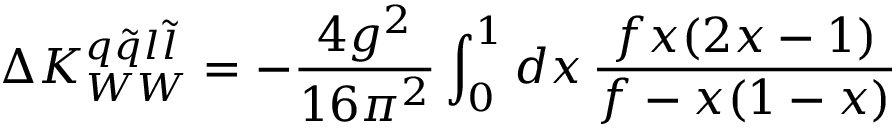Convert formula to latex. <formula><loc_0><loc_0><loc_500><loc_500>\Delta K _ { W W } ^ { q \tilde { q } l \tilde { l } } = - \frac { 4 g ^ { 2 } } { 1 6 \pi ^ { 2 } } \int _ { 0 } ^ { 1 } d x \, \frac { f x ( 2 x - 1 ) } { f - x ( 1 - x ) }</formula> 